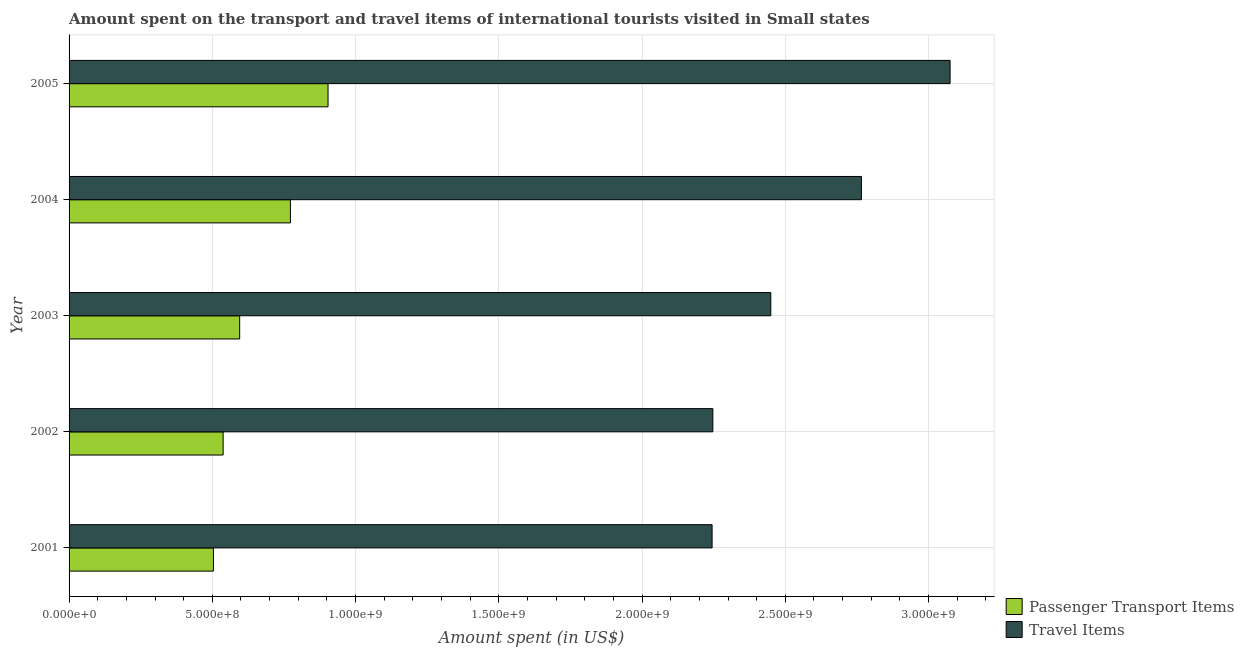How many groups of bars are there?
Keep it short and to the point. 5. Are the number of bars on each tick of the Y-axis equal?
Ensure brevity in your answer.  Yes. How many bars are there on the 2nd tick from the top?
Give a very brief answer. 2. What is the amount spent on passenger transport items in 2003?
Provide a succinct answer. 5.95e+08. Across all years, what is the maximum amount spent on passenger transport items?
Provide a succinct answer. 9.04e+08. Across all years, what is the minimum amount spent in travel items?
Make the answer very short. 2.24e+09. In which year was the amount spent in travel items maximum?
Your answer should be compact. 2005. What is the total amount spent in travel items in the graph?
Ensure brevity in your answer.  1.28e+1. What is the difference between the amount spent on passenger transport items in 2002 and that in 2003?
Offer a terse response. -5.77e+07. What is the difference between the amount spent in travel items in 2002 and the amount spent on passenger transport items in 2005?
Your response must be concise. 1.34e+09. What is the average amount spent in travel items per year?
Provide a succinct answer. 2.56e+09. In the year 2003, what is the difference between the amount spent in travel items and amount spent on passenger transport items?
Your answer should be very brief. 1.85e+09. In how many years, is the amount spent on passenger transport items greater than 2800000000 US$?
Ensure brevity in your answer.  0. What is the ratio of the amount spent in travel items in 2002 to that in 2004?
Your response must be concise. 0.81. Is the amount spent in travel items in 2002 less than that in 2003?
Offer a very short reply. Yes. Is the difference between the amount spent in travel items in 2002 and 2003 greater than the difference between the amount spent on passenger transport items in 2002 and 2003?
Provide a succinct answer. No. What is the difference between the highest and the second highest amount spent on passenger transport items?
Your answer should be very brief. 1.31e+08. What is the difference between the highest and the lowest amount spent on passenger transport items?
Your answer should be compact. 4.00e+08. Is the sum of the amount spent on passenger transport items in 2002 and 2003 greater than the maximum amount spent in travel items across all years?
Offer a very short reply. No. What does the 2nd bar from the top in 2003 represents?
Offer a very short reply. Passenger Transport Items. What does the 2nd bar from the bottom in 2004 represents?
Offer a terse response. Travel Items. Are the values on the major ticks of X-axis written in scientific E-notation?
Keep it short and to the point. Yes. Does the graph contain any zero values?
Provide a short and direct response. No. Does the graph contain grids?
Your answer should be compact. Yes. Where does the legend appear in the graph?
Ensure brevity in your answer.  Bottom right. How many legend labels are there?
Give a very brief answer. 2. How are the legend labels stacked?
Provide a short and direct response. Vertical. What is the title of the graph?
Provide a short and direct response. Amount spent on the transport and travel items of international tourists visited in Small states. What is the label or title of the X-axis?
Give a very brief answer. Amount spent (in US$). What is the label or title of the Y-axis?
Offer a very short reply. Year. What is the Amount spent (in US$) in Passenger Transport Items in 2001?
Provide a short and direct response. 5.04e+08. What is the Amount spent (in US$) in Travel Items in 2001?
Your answer should be compact. 2.24e+09. What is the Amount spent (in US$) in Passenger Transport Items in 2002?
Provide a short and direct response. 5.38e+08. What is the Amount spent (in US$) of Travel Items in 2002?
Make the answer very short. 2.25e+09. What is the Amount spent (in US$) of Passenger Transport Items in 2003?
Your response must be concise. 5.95e+08. What is the Amount spent (in US$) of Travel Items in 2003?
Offer a terse response. 2.45e+09. What is the Amount spent (in US$) in Passenger Transport Items in 2004?
Give a very brief answer. 7.73e+08. What is the Amount spent (in US$) of Travel Items in 2004?
Make the answer very short. 2.77e+09. What is the Amount spent (in US$) in Passenger Transport Items in 2005?
Keep it short and to the point. 9.04e+08. What is the Amount spent (in US$) in Travel Items in 2005?
Your answer should be compact. 3.08e+09. Across all years, what is the maximum Amount spent (in US$) in Passenger Transport Items?
Provide a succinct answer. 9.04e+08. Across all years, what is the maximum Amount spent (in US$) in Travel Items?
Provide a short and direct response. 3.08e+09. Across all years, what is the minimum Amount spent (in US$) in Passenger Transport Items?
Provide a short and direct response. 5.04e+08. Across all years, what is the minimum Amount spent (in US$) of Travel Items?
Ensure brevity in your answer.  2.24e+09. What is the total Amount spent (in US$) of Passenger Transport Items in the graph?
Your answer should be compact. 3.31e+09. What is the total Amount spent (in US$) of Travel Items in the graph?
Make the answer very short. 1.28e+1. What is the difference between the Amount spent (in US$) of Passenger Transport Items in 2001 and that in 2002?
Ensure brevity in your answer.  -3.39e+07. What is the difference between the Amount spent (in US$) of Travel Items in 2001 and that in 2002?
Your response must be concise. -2.64e+06. What is the difference between the Amount spent (in US$) in Passenger Transport Items in 2001 and that in 2003?
Ensure brevity in your answer.  -9.16e+07. What is the difference between the Amount spent (in US$) of Travel Items in 2001 and that in 2003?
Keep it short and to the point. -2.05e+08. What is the difference between the Amount spent (in US$) of Passenger Transport Items in 2001 and that in 2004?
Give a very brief answer. -2.69e+08. What is the difference between the Amount spent (in US$) in Travel Items in 2001 and that in 2004?
Provide a succinct answer. -5.21e+08. What is the difference between the Amount spent (in US$) in Passenger Transport Items in 2001 and that in 2005?
Your answer should be compact. -4.00e+08. What is the difference between the Amount spent (in US$) in Travel Items in 2001 and that in 2005?
Your response must be concise. -8.31e+08. What is the difference between the Amount spent (in US$) in Passenger Transport Items in 2002 and that in 2003?
Give a very brief answer. -5.77e+07. What is the difference between the Amount spent (in US$) in Travel Items in 2002 and that in 2003?
Your answer should be compact. -2.02e+08. What is the difference between the Amount spent (in US$) in Passenger Transport Items in 2002 and that in 2004?
Offer a terse response. -2.35e+08. What is the difference between the Amount spent (in US$) of Travel Items in 2002 and that in 2004?
Keep it short and to the point. -5.19e+08. What is the difference between the Amount spent (in US$) in Passenger Transport Items in 2002 and that in 2005?
Your answer should be compact. -3.66e+08. What is the difference between the Amount spent (in US$) in Travel Items in 2002 and that in 2005?
Give a very brief answer. -8.28e+08. What is the difference between the Amount spent (in US$) of Passenger Transport Items in 2003 and that in 2004?
Make the answer very short. -1.77e+08. What is the difference between the Amount spent (in US$) in Travel Items in 2003 and that in 2004?
Your response must be concise. -3.16e+08. What is the difference between the Amount spent (in US$) of Passenger Transport Items in 2003 and that in 2005?
Your answer should be compact. -3.08e+08. What is the difference between the Amount spent (in US$) in Travel Items in 2003 and that in 2005?
Your answer should be compact. -6.26e+08. What is the difference between the Amount spent (in US$) of Passenger Transport Items in 2004 and that in 2005?
Give a very brief answer. -1.31e+08. What is the difference between the Amount spent (in US$) of Travel Items in 2004 and that in 2005?
Your response must be concise. -3.09e+08. What is the difference between the Amount spent (in US$) of Passenger Transport Items in 2001 and the Amount spent (in US$) of Travel Items in 2002?
Offer a terse response. -1.74e+09. What is the difference between the Amount spent (in US$) of Passenger Transport Items in 2001 and the Amount spent (in US$) of Travel Items in 2003?
Your response must be concise. -1.95e+09. What is the difference between the Amount spent (in US$) in Passenger Transport Items in 2001 and the Amount spent (in US$) in Travel Items in 2004?
Ensure brevity in your answer.  -2.26e+09. What is the difference between the Amount spent (in US$) in Passenger Transport Items in 2001 and the Amount spent (in US$) in Travel Items in 2005?
Offer a terse response. -2.57e+09. What is the difference between the Amount spent (in US$) of Passenger Transport Items in 2002 and the Amount spent (in US$) of Travel Items in 2003?
Your response must be concise. -1.91e+09. What is the difference between the Amount spent (in US$) in Passenger Transport Items in 2002 and the Amount spent (in US$) in Travel Items in 2004?
Ensure brevity in your answer.  -2.23e+09. What is the difference between the Amount spent (in US$) in Passenger Transport Items in 2002 and the Amount spent (in US$) in Travel Items in 2005?
Your answer should be compact. -2.54e+09. What is the difference between the Amount spent (in US$) of Passenger Transport Items in 2003 and the Amount spent (in US$) of Travel Items in 2004?
Your response must be concise. -2.17e+09. What is the difference between the Amount spent (in US$) in Passenger Transport Items in 2003 and the Amount spent (in US$) in Travel Items in 2005?
Keep it short and to the point. -2.48e+09. What is the difference between the Amount spent (in US$) in Passenger Transport Items in 2004 and the Amount spent (in US$) in Travel Items in 2005?
Your answer should be compact. -2.30e+09. What is the average Amount spent (in US$) of Passenger Transport Items per year?
Offer a very short reply. 6.63e+08. What is the average Amount spent (in US$) of Travel Items per year?
Your answer should be compact. 2.56e+09. In the year 2001, what is the difference between the Amount spent (in US$) of Passenger Transport Items and Amount spent (in US$) of Travel Items?
Keep it short and to the point. -1.74e+09. In the year 2002, what is the difference between the Amount spent (in US$) in Passenger Transport Items and Amount spent (in US$) in Travel Items?
Provide a short and direct response. -1.71e+09. In the year 2003, what is the difference between the Amount spent (in US$) of Passenger Transport Items and Amount spent (in US$) of Travel Items?
Ensure brevity in your answer.  -1.85e+09. In the year 2004, what is the difference between the Amount spent (in US$) in Passenger Transport Items and Amount spent (in US$) in Travel Items?
Offer a terse response. -1.99e+09. In the year 2005, what is the difference between the Amount spent (in US$) in Passenger Transport Items and Amount spent (in US$) in Travel Items?
Give a very brief answer. -2.17e+09. What is the ratio of the Amount spent (in US$) of Passenger Transport Items in 2001 to that in 2002?
Provide a succinct answer. 0.94. What is the ratio of the Amount spent (in US$) in Passenger Transport Items in 2001 to that in 2003?
Make the answer very short. 0.85. What is the ratio of the Amount spent (in US$) of Travel Items in 2001 to that in 2003?
Give a very brief answer. 0.92. What is the ratio of the Amount spent (in US$) of Passenger Transport Items in 2001 to that in 2004?
Provide a succinct answer. 0.65. What is the ratio of the Amount spent (in US$) of Travel Items in 2001 to that in 2004?
Provide a short and direct response. 0.81. What is the ratio of the Amount spent (in US$) in Passenger Transport Items in 2001 to that in 2005?
Offer a very short reply. 0.56. What is the ratio of the Amount spent (in US$) of Travel Items in 2001 to that in 2005?
Ensure brevity in your answer.  0.73. What is the ratio of the Amount spent (in US$) in Passenger Transport Items in 2002 to that in 2003?
Offer a terse response. 0.9. What is the ratio of the Amount spent (in US$) in Travel Items in 2002 to that in 2003?
Your response must be concise. 0.92. What is the ratio of the Amount spent (in US$) in Passenger Transport Items in 2002 to that in 2004?
Give a very brief answer. 0.7. What is the ratio of the Amount spent (in US$) of Travel Items in 2002 to that in 2004?
Make the answer very short. 0.81. What is the ratio of the Amount spent (in US$) in Passenger Transport Items in 2002 to that in 2005?
Make the answer very short. 0.59. What is the ratio of the Amount spent (in US$) of Travel Items in 2002 to that in 2005?
Your answer should be compact. 0.73. What is the ratio of the Amount spent (in US$) of Passenger Transport Items in 2003 to that in 2004?
Offer a terse response. 0.77. What is the ratio of the Amount spent (in US$) of Travel Items in 2003 to that in 2004?
Offer a terse response. 0.89. What is the ratio of the Amount spent (in US$) of Passenger Transport Items in 2003 to that in 2005?
Keep it short and to the point. 0.66. What is the ratio of the Amount spent (in US$) of Travel Items in 2003 to that in 2005?
Provide a short and direct response. 0.8. What is the ratio of the Amount spent (in US$) of Passenger Transport Items in 2004 to that in 2005?
Provide a succinct answer. 0.85. What is the ratio of the Amount spent (in US$) in Travel Items in 2004 to that in 2005?
Ensure brevity in your answer.  0.9. What is the difference between the highest and the second highest Amount spent (in US$) of Passenger Transport Items?
Your response must be concise. 1.31e+08. What is the difference between the highest and the second highest Amount spent (in US$) of Travel Items?
Give a very brief answer. 3.09e+08. What is the difference between the highest and the lowest Amount spent (in US$) in Passenger Transport Items?
Make the answer very short. 4.00e+08. What is the difference between the highest and the lowest Amount spent (in US$) of Travel Items?
Ensure brevity in your answer.  8.31e+08. 